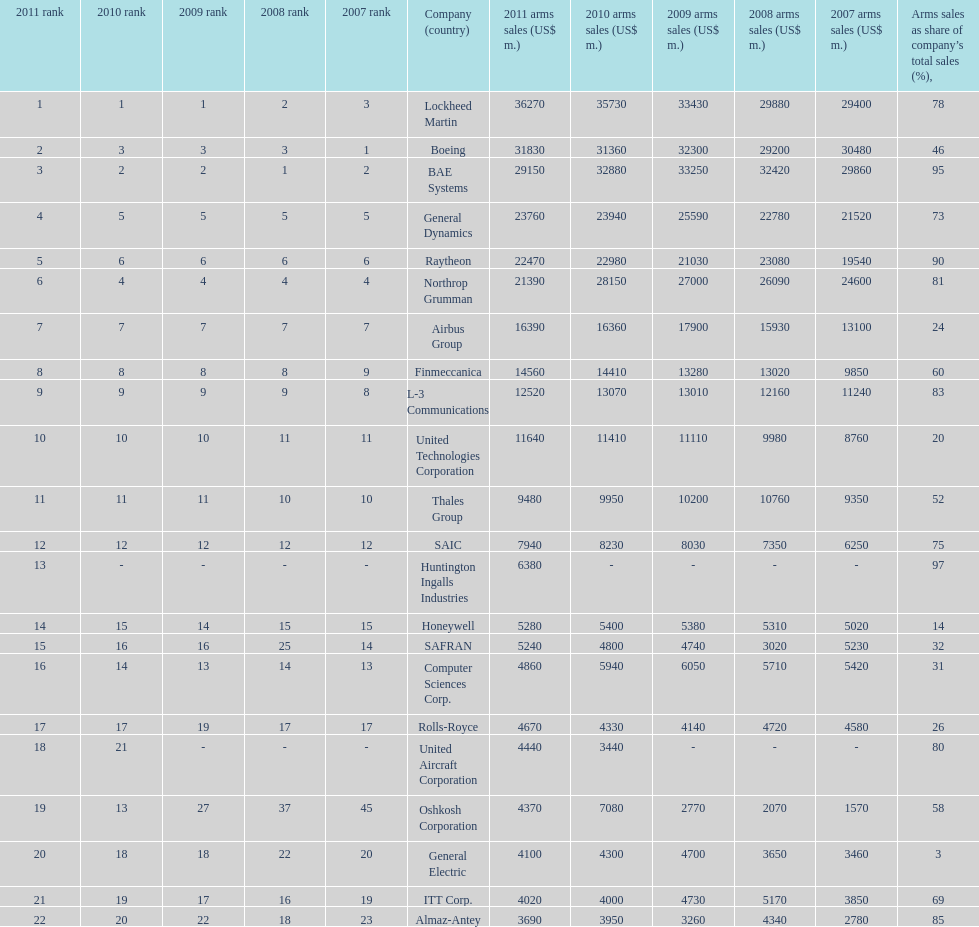In 2010, who had the lowest number of sales? United Aircraft Corporation. 